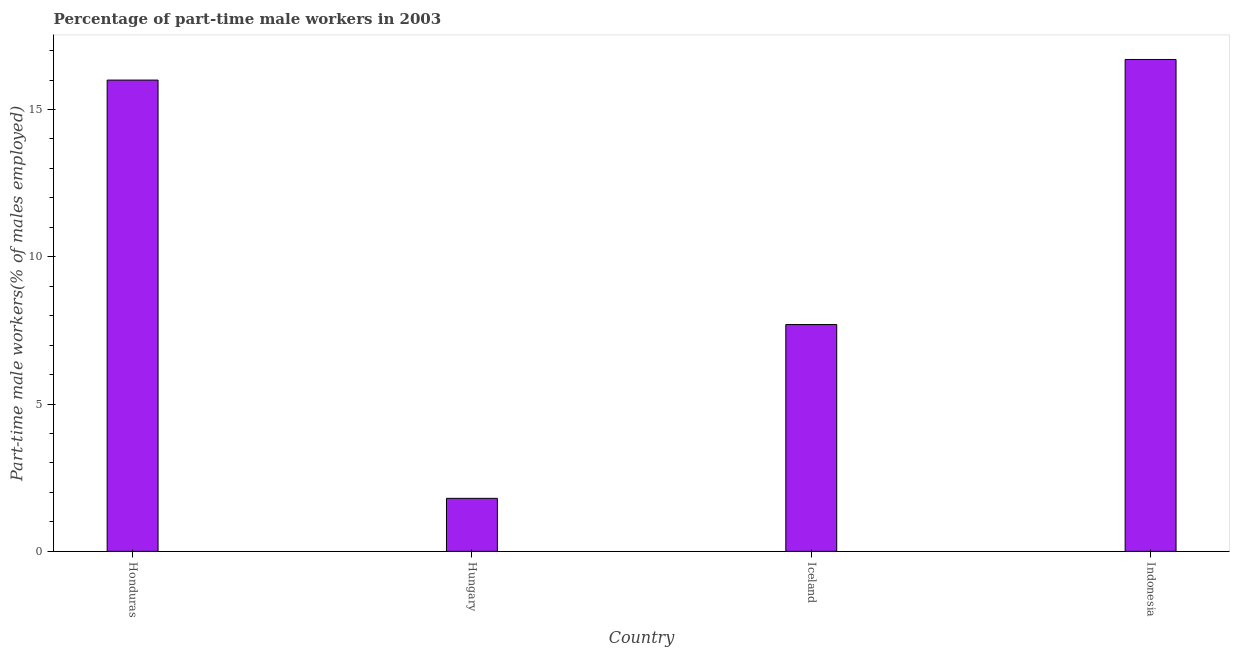Does the graph contain any zero values?
Offer a very short reply. No. Does the graph contain grids?
Offer a very short reply. No. What is the title of the graph?
Your response must be concise. Percentage of part-time male workers in 2003. What is the label or title of the Y-axis?
Your answer should be very brief. Part-time male workers(% of males employed). What is the percentage of part-time male workers in Honduras?
Make the answer very short. 16. Across all countries, what is the maximum percentage of part-time male workers?
Keep it short and to the point. 16.7. Across all countries, what is the minimum percentage of part-time male workers?
Provide a succinct answer. 1.8. In which country was the percentage of part-time male workers minimum?
Offer a very short reply. Hungary. What is the sum of the percentage of part-time male workers?
Keep it short and to the point. 42.2. What is the difference between the percentage of part-time male workers in Iceland and Indonesia?
Offer a very short reply. -9. What is the average percentage of part-time male workers per country?
Your answer should be very brief. 10.55. What is the median percentage of part-time male workers?
Provide a succinct answer. 11.85. What is the ratio of the percentage of part-time male workers in Iceland to that in Indonesia?
Ensure brevity in your answer.  0.46. Is the difference between the percentage of part-time male workers in Honduras and Hungary greater than the difference between any two countries?
Give a very brief answer. No. What is the difference between the highest and the second highest percentage of part-time male workers?
Your response must be concise. 0.7. What is the difference between the highest and the lowest percentage of part-time male workers?
Your answer should be very brief. 14.9. How many bars are there?
Your response must be concise. 4. Are all the bars in the graph horizontal?
Provide a short and direct response. No. How many countries are there in the graph?
Offer a very short reply. 4. What is the difference between two consecutive major ticks on the Y-axis?
Your answer should be very brief. 5. Are the values on the major ticks of Y-axis written in scientific E-notation?
Your answer should be very brief. No. What is the Part-time male workers(% of males employed) in Honduras?
Keep it short and to the point. 16. What is the Part-time male workers(% of males employed) of Hungary?
Offer a very short reply. 1.8. What is the Part-time male workers(% of males employed) in Iceland?
Offer a terse response. 7.7. What is the Part-time male workers(% of males employed) of Indonesia?
Your answer should be very brief. 16.7. What is the difference between the Part-time male workers(% of males employed) in Honduras and Hungary?
Keep it short and to the point. 14.2. What is the difference between the Part-time male workers(% of males employed) in Honduras and Iceland?
Offer a terse response. 8.3. What is the difference between the Part-time male workers(% of males employed) in Honduras and Indonesia?
Your answer should be very brief. -0.7. What is the difference between the Part-time male workers(% of males employed) in Hungary and Iceland?
Your answer should be compact. -5.9. What is the difference between the Part-time male workers(% of males employed) in Hungary and Indonesia?
Your response must be concise. -14.9. What is the difference between the Part-time male workers(% of males employed) in Iceland and Indonesia?
Provide a short and direct response. -9. What is the ratio of the Part-time male workers(% of males employed) in Honduras to that in Hungary?
Keep it short and to the point. 8.89. What is the ratio of the Part-time male workers(% of males employed) in Honduras to that in Iceland?
Make the answer very short. 2.08. What is the ratio of the Part-time male workers(% of males employed) in Honduras to that in Indonesia?
Keep it short and to the point. 0.96. What is the ratio of the Part-time male workers(% of males employed) in Hungary to that in Iceland?
Provide a succinct answer. 0.23. What is the ratio of the Part-time male workers(% of males employed) in Hungary to that in Indonesia?
Your answer should be compact. 0.11. What is the ratio of the Part-time male workers(% of males employed) in Iceland to that in Indonesia?
Offer a terse response. 0.46. 